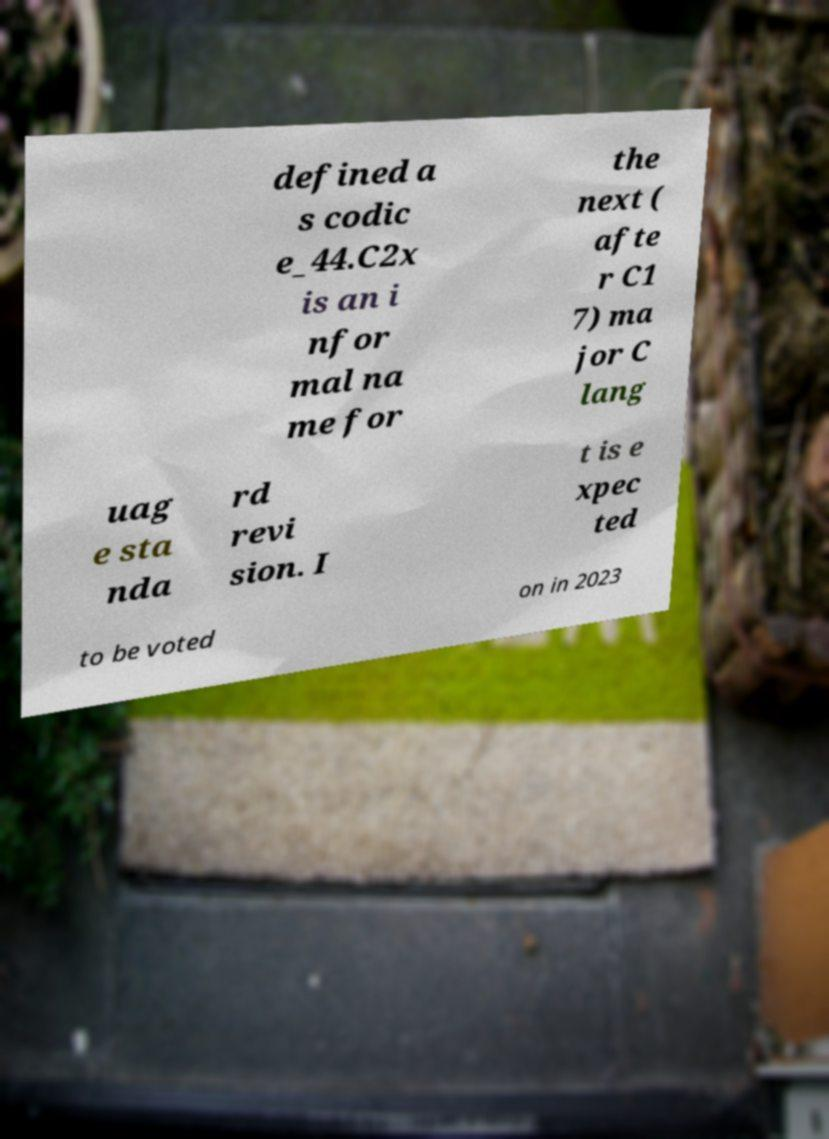Could you extract and type out the text from this image? defined a s codic e_44.C2x is an i nfor mal na me for the next ( afte r C1 7) ma jor C lang uag e sta nda rd revi sion. I t is e xpec ted to be voted on in 2023 